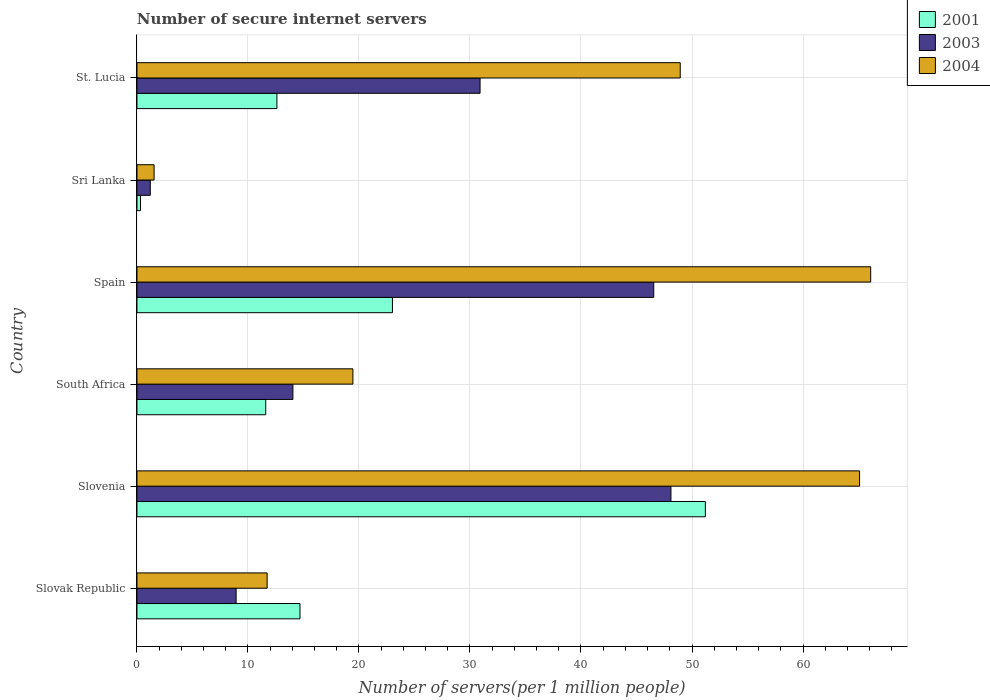How many groups of bars are there?
Your answer should be compact. 6. Are the number of bars on each tick of the Y-axis equal?
Offer a terse response. Yes. How many bars are there on the 6th tick from the top?
Make the answer very short. 3. How many bars are there on the 1st tick from the bottom?
Keep it short and to the point. 3. What is the label of the 4th group of bars from the top?
Provide a short and direct response. South Africa. What is the number of secure internet servers in 2001 in Slovak Republic?
Keep it short and to the point. 14.69. Across all countries, what is the maximum number of secure internet servers in 2004?
Your answer should be very brief. 66.1. Across all countries, what is the minimum number of secure internet servers in 2003?
Keep it short and to the point. 1.2. In which country was the number of secure internet servers in 2001 maximum?
Make the answer very short. Slovenia. In which country was the number of secure internet servers in 2003 minimum?
Ensure brevity in your answer.  Sri Lanka. What is the total number of secure internet servers in 2003 in the graph?
Offer a terse response. 149.75. What is the difference between the number of secure internet servers in 2004 in Slovak Republic and that in St. Lucia?
Your response must be concise. -37.21. What is the difference between the number of secure internet servers in 2001 in Sri Lanka and the number of secure internet servers in 2003 in Slovak Republic?
Provide a succinct answer. -8.61. What is the average number of secure internet servers in 2001 per country?
Ensure brevity in your answer.  18.91. What is the difference between the number of secure internet servers in 2001 and number of secure internet servers in 2004 in Spain?
Your answer should be very brief. -43.08. What is the ratio of the number of secure internet servers in 2001 in Slovenia to that in Sri Lanka?
Make the answer very short. 160.41. What is the difference between the highest and the second highest number of secure internet servers in 2003?
Your response must be concise. 1.55. What is the difference between the highest and the lowest number of secure internet servers in 2001?
Your answer should be very brief. 50.88. What does the 3rd bar from the top in St. Lucia represents?
Offer a very short reply. 2001. How many bars are there?
Ensure brevity in your answer.  18. Are all the bars in the graph horizontal?
Offer a terse response. Yes. Are the values on the major ticks of X-axis written in scientific E-notation?
Your answer should be compact. No. Does the graph contain any zero values?
Provide a succinct answer. No. Does the graph contain grids?
Make the answer very short. Yes. How are the legend labels stacked?
Your answer should be very brief. Vertical. What is the title of the graph?
Offer a very short reply. Number of secure internet servers. What is the label or title of the X-axis?
Your answer should be very brief. Number of servers(per 1 million people). What is the label or title of the Y-axis?
Make the answer very short. Country. What is the Number of servers(per 1 million people) in 2001 in Slovak Republic?
Give a very brief answer. 14.69. What is the Number of servers(per 1 million people) of 2003 in Slovak Republic?
Keep it short and to the point. 8.93. What is the Number of servers(per 1 million people) of 2004 in Slovak Republic?
Provide a succinct answer. 11.73. What is the Number of servers(per 1 million people) of 2001 in Slovenia?
Your response must be concise. 51.2. What is the Number of servers(per 1 million people) of 2003 in Slovenia?
Give a very brief answer. 48.1. What is the Number of servers(per 1 million people) in 2004 in Slovenia?
Offer a very short reply. 65.1. What is the Number of servers(per 1 million people) of 2001 in South Africa?
Your answer should be compact. 11.6. What is the Number of servers(per 1 million people) in 2003 in South Africa?
Provide a short and direct response. 14.05. What is the Number of servers(per 1 million people) of 2004 in South Africa?
Your answer should be very brief. 19.45. What is the Number of servers(per 1 million people) of 2001 in Spain?
Provide a succinct answer. 23.02. What is the Number of servers(per 1 million people) in 2003 in Spain?
Ensure brevity in your answer.  46.55. What is the Number of servers(per 1 million people) of 2004 in Spain?
Ensure brevity in your answer.  66.1. What is the Number of servers(per 1 million people) of 2001 in Sri Lanka?
Keep it short and to the point. 0.32. What is the Number of servers(per 1 million people) of 2003 in Sri Lanka?
Offer a terse response. 1.2. What is the Number of servers(per 1 million people) of 2004 in Sri Lanka?
Provide a short and direct response. 1.54. What is the Number of servers(per 1 million people) in 2001 in St. Lucia?
Provide a short and direct response. 12.61. What is the Number of servers(per 1 million people) in 2003 in St. Lucia?
Ensure brevity in your answer.  30.91. What is the Number of servers(per 1 million people) in 2004 in St. Lucia?
Your answer should be compact. 48.94. Across all countries, what is the maximum Number of servers(per 1 million people) in 2001?
Provide a short and direct response. 51.2. Across all countries, what is the maximum Number of servers(per 1 million people) in 2003?
Provide a succinct answer. 48.1. Across all countries, what is the maximum Number of servers(per 1 million people) in 2004?
Keep it short and to the point. 66.1. Across all countries, what is the minimum Number of servers(per 1 million people) of 2001?
Keep it short and to the point. 0.32. Across all countries, what is the minimum Number of servers(per 1 million people) of 2003?
Your answer should be very brief. 1.2. Across all countries, what is the minimum Number of servers(per 1 million people) in 2004?
Offer a very short reply. 1.54. What is the total Number of servers(per 1 million people) of 2001 in the graph?
Your answer should be very brief. 113.43. What is the total Number of servers(per 1 million people) in 2003 in the graph?
Ensure brevity in your answer.  149.75. What is the total Number of servers(per 1 million people) in 2004 in the graph?
Offer a terse response. 212.86. What is the difference between the Number of servers(per 1 million people) in 2001 in Slovak Republic and that in Slovenia?
Ensure brevity in your answer.  -36.52. What is the difference between the Number of servers(per 1 million people) of 2003 in Slovak Republic and that in Slovenia?
Your answer should be compact. -39.17. What is the difference between the Number of servers(per 1 million people) in 2004 in Slovak Republic and that in Slovenia?
Offer a very short reply. -53.37. What is the difference between the Number of servers(per 1 million people) of 2001 in Slovak Republic and that in South Africa?
Offer a terse response. 3.09. What is the difference between the Number of servers(per 1 million people) in 2003 in Slovak Republic and that in South Africa?
Offer a terse response. -5.12. What is the difference between the Number of servers(per 1 million people) in 2004 in Slovak Republic and that in South Africa?
Provide a short and direct response. -7.73. What is the difference between the Number of servers(per 1 million people) of 2001 in Slovak Republic and that in Spain?
Give a very brief answer. -8.33. What is the difference between the Number of servers(per 1 million people) of 2003 in Slovak Republic and that in Spain?
Give a very brief answer. -37.62. What is the difference between the Number of servers(per 1 million people) in 2004 in Slovak Republic and that in Spain?
Give a very brief answer. -54.37. What is the difference between the Number of servers(per 1 million people) in 2001 in Slovak Republic and that in Sri Lanka?
Offer a terse response. 14.37. What is the difference between the Number of servers(per 1 million people) of 2003 in Slovak Republic and that in Sri Lanka?
Make the answer very short. 7.73. What is the difference between the Number of servers(per 1 million people) in 2004 in Slovak Republic and that in Sri Lanka?
Keep it short and to the point. 10.18. What is the difference between the Number of servers(per 1 million people) in 2001 in Slovak Republic and that in St. Lucia?
Make the answer very short. 2.08. What is the difference between the Number of servers(per 1 million people) of 2003 in Slovak Republic and that in St. Lucia?
Offer a very short reply. -21.98. What is the difference between the Number of servers(per 1 million people) in 2004 in Slovak Republic and that in St. Lucia?
Provide a short and direct response. -37.21. What is the difference between the Number of servers(per 1 million people) of 2001 in Slovenia and that in South Africa?
Your response must be concise. 39.6. What is the difference between the Number of servers(per 1 million people) in 2003 in Slovenia and that in South Africa?
Your answer should be very brief. 34.05. What is the difference between the Number of servers(per 1 million people) of 2004 in Slovenia and that in South Africa?
Your answer should be very brief. 45.64. What is the difference between the Number of servers(per 1 million people) of 2001 in Slovenia and that in Spain?
Ensure brevity in your answer.  28.19. What is the difference between the Number of servers(per 1 million people) in 2003 in Slovenia and that in Spain?
Offer a terse response. 1.55. What is the difference between the Number of servers(per 1 million people) of 2004 in Slovenia and that in Spain?
Your answer should be very brief. -1. What is the difference between the Number of servers(per 1 million people) in 2001 in Slovenia and that in Sri Lanka?
Provide a short and direct response. 50.88. What is the difference between the Number of servers(per 1 million people) in 2003 in Slovenia and that in Sri Lanka?
Your response must be concise. 46.9. What is the difference between the Number of servers(per 1 million people) of 2004 in Slovenia and that in Sri Lanka?
Make the answer very short. 63.55. What is the difference between the Number of servers(per 1 million people) of 2001 in Slovenia and that in St. Lucia?
Make the answer very short. 38.6. What is the difference between the Number of servers(per 1 million people) in 2003 in Slovenia and that in St. Lucia?
Ensure brevity in your answer.  17.19. What is the difference between the Number of servers(per 1 million people) of 2004 in Slovenia and that in St. Lucia?
Give a very brief answer. 16.16. What is the difference between the Number of servers(per 1 million people) of 2001 in South Africa and that in Spain?
Provide a short and direct response. -11.41. What is the difference between the Number of servers(per 1 million people) in 2003 in South Africa and that in Spain?
Give a very brief answer. -32.51. What is the difference between the Number of servers(per 1 million people) of 2004 in South Africa and that in Spain?
Keep it short and to the point. -46.64. What is the difference between the Number of servers(per 1 million people) of 2001 in South Africa and that in Sri Lanka?
Provide a succinct answer. 11.28. What is the difference between the Number of servers(per 1 million people) in 2003 in South Africa and that in Sri Lanka?
Provide a short and direct response. 12.85. What is the difference between the Number of servers(per 1 million people) in 2004 in South Africa and that in Sri Lanka?
Your response must be concise. 17.91. What is the difference between the Number of servers(per 1 million people) in 2001 in South Africa and that in St. Lucia?
Your answer should be compact. -1.01. What is the difference between the Number of servers(per 1 million people) in 2003 in South Africa and that in St. Lucia?
Your answer should be very brief. -16.86. What is the difference between the Number of servers(per 1 million people) in 2004 in South Africa and that in St. Lucia?
Make the answer very short. -29.49. What is the difference between the Number of servers(per 1 million people) of 2001 in Spain and that in Sri Lanka?
Keep it short and to the point. 22.7. What is the difference between the Number of servers(per 1 million people) in 2003 in Spain and that in Sri Lanka?
Offer a very short reply. 45.35. What is the difference between the Number of servers(per 1 million people) in 2004 in Spain and that in Sri Lanka?
Offer a very short reply. 64.55. What is the difference between the Number of servers(per 1 million people) in 2001 in Spain and that in St. Lucia?
Offer a terse response. 10.41. What is the difference between the Number of servers(per 1 million people) in 2003 in Spain and that in St. Lucia?
Provide a succinct answer. 15.65. What is the difference between the Number of servers(per 1 million people) of 2004 in Spain and that in St. Lucia?
Keep it short and to the point. 17.16. What is the difference between the Number of servers(per 1 million people) in 2001 in Sri Lanka and that in St. Lucia?
Make the answer very short. -12.29. What is the difference between the Number of servers(per 1 million people) of 2003 in Sri Lanka and that in St. Lucia?
Give a very brief answer. -29.71. What is the difference between the Number of servers(per 1 million people) of 2004 in Sri Lanka and that in St. Lucia?
Keep it short and to the point. -47.4. What is the difference between the Number of servers(per 1 million people) of 2001 in Slovak Republic and the Number of servers(per 1 million people) of 2003 in Slovenia?
Your answer should be compact. -33.42. What is the difference between the Number of servers(per 1 million people) in 2001 in Slovak Republic and the Number of servers(per 1 million people) in 2004 in Slovenia?
Your answer should be very brief. -50.41. What is the difference between the Number of servers(per 1 million people) of 2003 in Slovak Republic and the Number of servers(per 1 million people) of 2004 in Slovenia?
Provide a succinct answer. -56.16. What is the difference between the Number of servers(per 1 million people) in 2001 in Slovak Republic and the Number of servers(per 1 million people) in 2003 in South Africa?
Offer a very short reply. 0.64. What is the difference between the Number of servers(per 1 million people) in 2001 in Slovak Republic and the Number of servers(per 1 million people) in 2004 in South Africa?
Your answer should be compact. -4.77. What is the difference between the Number of servers(per 1 million people) of 2003 in Slovak Republic and the Number of servers(per 1 million people) of 2004 in South Africa?
Provide a succinct answer. -10.52. What is the difference between the Number of servers(per 1 million people) of 2001 in Slovak Republic and the Number of servers(per 1 million people) of 2003 in Spain?
Ensure brevity in your answer.  -31.87. What is the difference between the Number of servers(per 1 million people) of 2001 in Slovak Republic and the Number of servers(per 1 million people) of 2004 in Spain?
Give a very brief answer. -51.41. What is the difference between the Number of servers(per 1 million people) of 2003 in Slovak Republic and the Number of servers(per 1 million people) of 2004 in Spain?
Make the answer very short. -57.16. What is the difference between the Number of servers(per 1 million people) of 2001 in Slovak Republic and the Number of servers(per 1 million people) of 2003 in Sri Lanka?
Your answer should be compact. 13.49. What is the difference between the Number of servers(per 1 million people) of 2001 in Slovak Republic and the Number of servers(per 1 million people) of 2004 in Sri Lanka?
Keep it short and to the point. 13.14. What is the difference between the Number of servers(per 1 million people) in 2003 in Slovak Republic and the Number of servers(per 1 million people) in 2004 in Sri Lanka?
Your answer should be very brief. 7.39. What is the difference between the Number of servers(per 1 million people) in 2001 in Slovak Republic and the Number of servers(per 1 million people) in 2003 in St. Lucia?
Make the answer very short. -16.22. What is the difference between the Number of servers(per 1 million people) in 2001 in Slovak Republic and the Number of servers(per 1 million people) in 2004 in St. Lucia?
Provide a succinct answer. -34.25. What is the difference between the Number of servers(per 1 million people) of 2003 in Slovak Republic and the Number of servers(per 1 million people) of 2004 in St. Lucia?
Give a very brief answer. -40.01. What is the difference between the Number of servers(per 1 million people) in 2001 in Slovenia and the Number of servers(per 1 million people) in 2003 in South Africa?
Ensure brevity in your answer.  37.16. What is the difference between the Number of servers(per 1 million people) in 2001 in Slovenia and the Number of servers(per 1 million people) in 2004 in South Africa?
Offer a terse response. 31.75. What is the difference between the Number of servers(per 1 million people) in 2003 in Slovenia and the Number of servers(per 1 million people) in 2004 in South Africa?
Your answer should be very brief. 28.65. What is the difference between the Number of servers(per 1 million people) in 2001 in Slovenia and the Number of servers(per 1 million people) in 2003 in Spain?
Offer a very short reply. 4.65. What is the difference between the Number of servers(per 1 million people) of 2001 in Slovenia and the Number of servers(per 1 million people) of 2004 in Spain?
Ensure brevity in your answer.  -14.89. What is the difference between the Number of servers(per 1 million people) in 2003 in Slovenia and the Number of servers(per 1 million people) in 2004 in Spain?
Offer a terse response. -17.99. What is the difference between the Number of servers(per 1 million people) in 2001 in Slovenia and the Number of servers(per 1 million people) in 2003 in Sri Lanka?
Keep it short and to the point. 50. What is the difference between the Number of servers(per 1 million people) of 2001 in Slovenia and the Number of servers(per 1 million people) of 2004 in Sri Lanka?
Your answer should be very brief. 49.66. What is the difference between the Number of servers(per 1 million people) in 2003 in Slovenia and the Number of servers(per 1 million people) in 2004 in Sri Lanka?
Provide a succinct answer. 46.56. What is the difference between the Number of servers(per 1 million people) in 2001 in Slovenia and the Number of servers(per 1 million people) in 2003 in St. Lucia?
Make the answer very short. 20.29. What is the difference between the Number of servers(per 1 million people) in 2001 in Slovenia and the Number of servers(per 1 million people) in 2004 in St. Lucia?
Ensure brevity in your answer.  2.26. What is the difference between the Number of servers(per 1 million people) in 2003 in Slovenia and the Number of servers(per 1 million people) in 2004 in St. Lucia?
Provide a short and direct response. -0.84. What is the difference between the Number of servers(per 1 million people) in 2001 in South Africa and the Number of servers(per 1 million people) in 2003 in Spain?
Offer a terse response. -34.95. What is the difference between the Number of servers(per 1 million people) in 2001 in South Africa and the Number of servers(per 1 million people) in 2004 in Spain?
Your answer should be very brief. -54.5. What is the difference between the Number of servers(per 1 million people) of 2003 in South Africa and the Number of servers(per 1 million people) of 2004 in Spain?
Provide a short and direct response. -52.05. What is the difference between the Number of servers(per 1 million people) in 2001 in South Africa and the Number of servers(per 1 million people) in 2003 in Sri Lanka?
Your answer should be compact. 10.4. What is the difference between the Number of servers(per 1 million people) in 2001 in South Africa and the Number of servers(per 1 million people) in 2004 in Sri Lanka?
Make the answer very short. 10.06. What is the difference between the Number of servers(per 1 million people) in 2003 in South Africa and the Number of servers(per 1 million people) in 2004 in Sri Lanka?
Provide a short and direct response. 12.5. What is the difference between the Number of servers(per 1 million people) in 2001 in South Africa and the Number of servers(per 1 million people) in 2003 in St. Lucia?
Ensure brevity in your answer.  -19.31. What is the difference between the Number of servers(per 1 million people) of 2001 in South Africa and the Number of servers(per 1 million people) of 2004 in St. Lucia?
Provide a succinct answer. -37.34. What is the difference between the Number of servers(per 1 million people) of 2003 in South Africa and the Number of servers(per 1 million people) of 2004 in St. Lucia?
Give a very brief answer. -34.89. What is the difference between the Number of servers(per 1 million people) of 2001 in Spain and the Number of servers(per 1 million people) of 2003 in Sri Lanka?
Provide a short and direct response. 21.82. What is the difference between the Number of servers(per 1 million people) in 2001 in Spain and the Number of servers(per 1 million people) in 2004 in Sri Lanka?
Provide a succinct answer. 21.47. What is the difference between the Number of servers(per 1 million people) of 2003 in Spain and the Number of servers(per 1 million people) of 2004 in Sri Lanka?
Your answer should be very brief. 45.01. What is the difference between the Number of servers(per 1 million people) of 2001 in Spain and the Number of servers(per 1 million people) of 2003 in St. Lucia?
Offer a very short reply. -7.89. What is the difference between the Number of servers(per 1 million people) of 2001 in Spain and the Number of servers(per 1 million people) of 2004 in St. Lucia?
Ensure brevity in your answer.  -25.93. What is the difference between the Number of servers(per 1 million people) in 2003 in Spain and the Number of servers(per 1 million people) in 2004 in St. Lucia?
Provide a succinct answer. -2.39. What is the difference between the Number of servers(per 1 million people) of 2001 in Sri Lanka and the Number of servers(per 1 million people) of 2003 in St. Lucia?
Give a very brief answer. -30.59. What is the difference between the Number of servers(per 1 million people) of 2001 in Sri Lanka and the Number of servers(per 1 million people) of 2004 in St. Lucia?
Keep it short and to the point. -48.62. What is the difference between the Number of servers(per 1 million people) of 2003 in Sri Lanka and the Number of servers(per 1 million people) of 2004 in St. Lucia?
Your response must be concise. -47.74. What is the average Number of servers(per 1 million people) of 2001 per country?
Make the answer very short. 18.91. What is the average Number of servers(per 1 million people) in 2003 per country?
Ensure brevity in your answer.  24.96. What is the average Number of servers(per 1 million people) of 2004 per country?
Provide a succinct answer. 35.48. What is the difference between the Number of servers(per 1 million people) of 2001 and Number of servers(per 1 million people) of 2003 in Slovak Republic?
Offer a very short reply. 5.75. What is the difference between the Number of servers(per 1 million people) in 2001 and Number of servers(per 1 million people) in 2004 in Slovak Republic?
Make the answer very short. 2.96. What is the difference between the Number of servers(per 1 million people) of 2003 and Number of servers(per 1 million people) of 2004 in Slovak Republic?
Offer a very short reply. -2.79. What is the difference between the Number of servers(per 1 million people) of 2001 and Number of servers(per 1 million people) of 2003 in Slovenia?
Provide a succinct answer. 3.1. What is the difference between the Number of servers(per 1 million people) in 2001 and Number of servers(per 1 million people) in 2004 in Slovenia?
Give a very brief answer. -13.89. What is the difference between the Number of servers(per 1 million people) in 2003 and Number of servers(per 1 million people) in 2004 in Slovenia?
Offer a very short reply. -16.99. What is the difference between the Number of servers(per 1 million people) of 2001 and Number of servers(per 1 million people) of 2003 in South Africa?
Give a very brief answer. -2.45. What is the difference between the Number of servers(per 1 million people) of 2001 and Number of servers(per 1 million people) of 2004 in South Africa?
Your response must be concise. -7.85. What is the difference between the Number of servers(per 1 million people) in 2003 and Number of servers(per 1 million people) in 2004 in South Africa?
Provide a short and direct response. -5.41. What is the difference between the Number of servers(per 1 million people) in 2001 and Number of servers(per 1 million people) in 2003 in Spain?
Provide a short and direct response. -23.54. What is the difference between the Number of servers(per 1 million people) in 2001 and Number of servers(per 1 million people) in 2004 in Spain?
Keep it short and to the point. -43.08. What is the difference between the Number of servers(per 1 million people) in 2003 and Number of servers(per 1 million people) in 2004 in Spain?
Offer a terse response. -19.54. What is the difference between the Number of servers(per 1 million people) of 2001 and Number of servers(per 1 million people) of 2003 in Sri Lanka?
Keep it short and to the point. -0.88. What is the difference between the Number of servers(per 1 million people) of 2001 and Number of servers(per 1 million people) of 2004 in Sri Lanka?
Offer a terse response. -1.22. What is the difference between the Number of servers(per 1 million people) in 2003 and Number of servers(per 1 million people) in 2004 in Sri Lanka?
Make the answer very short. -0.34. What is the difference between the Number of servers(per 1 million people) in 2001 and Number of servers(per 1 million people) in 2003 in St. Lucia?
Your response must be concise. -18.3. What is the difference between the Number of servers(per 1 million people) in 2001 and Number of servers(per 1 million people) in 2004 in St. Lucia?
Your answer should be compact. -36.33. What is the difference between the Number of servers(per 1 million people) of 2003 and Number of servers(per 1 million people) of 2004 in St. Lucia?
Offer a very short reply. -18.03. What is the ratio of the Number of servers(per 1 million people) in 2001 in Slovak Republic to that in Slovenia?
Your response must be concise. 0.29. What is the ratio of the Number of servers(per 1 million people) of 2003 in Slovak Republic to that in Slovenia?
Your answer should be very brief. 0.19. What is the ratio of the Number of servers(per 1 million people) of 2004 in Slovak Republic to that in Slovenia?
Make the answer very short. 0.18. What is the ratio of the Number of servers(per 1 million people) of 2001 in Slovak Republic to that in South Africa?
Offer a very short reply. 1.27. What is the ratio of the Number of servers(per 1 million people) of 2003 in Slovak Republic to that in South Africa?
Offer a very short reply. 0.64. What is the ratio of the Number of servers(per 1 million people) of 2004 in Slovak Republic to that in South Africa?
Offer a terse response. 0.6. What is the ratio of the Number of servers(per 1 million people) of 2001 in Slovak Republic to that in Spain?
Provide a succinct answer. 0.64. What is the ratio of the Number of servers(per 1 million people) in 2003 in Slovak Republic to that in Spain?
Offer a terse response. 0.19. What is the ratio of the Number of servers(per 1 million people) in 2004 in Slovak Republic to that in Spain?
Ensure brevity in your answer.  0.18. What is the ratio of the Number of servers(per 1 million people) of 2001 in Slovak Republic to that in Sri Lanka?
Make the answer very short. 46.01. What is the ratio of the Number of servers(per 1 million people) in 2003 in Slovak Republic to that in Sri Lanka?
Your response must be concise. 7.45. What is the ratio of the Number of servers(per 1 million people) in 2004 in Slovak Republic to that in Sri Lanka?
Keep it short and to the point. 7.6. What is the ratio of the Number of servers(per 1 million people) of 2001 in Slovak Republic to that in St. Lucia?
Provide a succinct answer. 1.17. What is the ratio of the Number of servers(per 1 million people) in 2003 in Slovak Republic to that in St. Lucia?
Keep it short and to the point. 0.29. What is the ratio of the Number of servers(per 1 million people) of 2004 in Slovak Republic to that in St. Lucia?
Offer a terse response. 0.24. What is the ratio of the Number of servers(per 1 million people) in 2001 in Slovenia to that in South Africa?
Your answer should be compact. 4.41. What is the ratio of the Number of servers(per 1 million people) of 2003 in Slovenia to that in South Africa?
Provide a short and direct response. 3.42. What is the ratio of the Number of servers(per 1 million people) of 2004 in Slovenia to that in South Africa?
Your answer should be compact. 3.35. What is the ratio of the Number of servers(per 1 million people) in 2001 in Slovenia to that in Spain?
Make the answer very short. 2.22. What is the ratio of the Number of servers(per 1 million people) in 2004 in Slovenia to that in Spain?
Make the answer very short. 0.98. What is the ratio of the Number of servers(per 1 million people) in 2001 in Slovenia to that in Sri Lanka?
Your answer should be very brief. 160.41. What is the ratio of the Number of servers(per 1 million people) in 2003 in Slovenia to that in Sri Lanka?
Give a very brief answer. 40.1. What is the ratio of the Number of servers(per 1 million people) of 2004 in Slovenia to that in Sri Lanka?
Provide a short and direct response. 42.17. What is the ratio of the Number of servers(per 1 million people) of 2001 in Slovenia to that in St. Lucia?
Your answer should be very brief. 4.06. What is the ratio of the Number of servers(per 1 million people) of 2003 in Slovenia to that in St. Lucia?
Offer a very short reply. 1.56. What is the ratio of the Number of servers(per 1 million people) in 2004 in Slovenia to that in St. Lucia?
Your answer should be compact. 1.33. What is the ratio of the Number of servers(per 1 million people) of 2001 in South Africa to that in Spain?
Your response must be concise. 0.5. What is the ratio of the Number of servers(per 1 million people) in 2003 in South Africa to that in Spain?
Offer a terse response. 0.3. What is the ratio of the Number of servers(per 1 million people) of 2004 in South Africa to that in Spain?
Offer a very short reply. 0.29. What is the ratio of the Number of servers(per 1 million people) in 2001 in South Africa to that in Sri Lanka?
Give a very brief answer. 36.34. What is the ratio of the Number of servers(per 1 million people) in 2003 in South Africa to that in Sri Lanka?
Your answer should be very brief. 11.71. What is the ratio of the Number of servers(per 1 million people) in 2004 in South Africa to that in Sri Lanka?
Offer a terse response. 12.6. What is the ratio of the Number of servers(per 1 million people) in 2001 in South Africa to that in St. Lucia?
Provide a short and direct response. 0.92. What is the ratio of the Number of servers(per 1 million people) in 2003 in South Africa to that in St. Lucia?
Your answer should be compact. 0.45. What is the ratio of the Number of servers(per 1 million people) in 2004 in South Africa to that in St. Lucia?
Your answer should be very brief. 0.4. What is the ratio of the Number of servers(per 1 million people) of 2001 in Spain to that in Sri Lanka?
Your answer should be compact. 72.1. What is the ratio of the Number of servers(per 1 million people) in 2003 in Spain to that in Sri Lanka?
Your response must be concise. 38.81. What is the ratio of the Number of servers(per 1 million people) in 2004 in Spain to that in Sri Lanka?
Offer a terse response. 42.82. What is the ratio of the Number of servers(per 1 million people) in 2001 in Spain to that in St. Lucia?
Your answer should be compact. 1.83. What is the ratio of the Number of servers(per 1 million people) of 2003 in Spain to that in St. Lucia?
Provide a short and direct response. 1.51. What is the ratio of the Number of servers(per 1 million people) in 2004 in Spain to that in St. Lucia?
Ensure brevity in your answer.  1.35. What is the ratio of the Number of servers(per 1 million people) of 2001 in Sri Lanka to that in St. Lucia?
Offer a very short reply. 0.03. What is the ratio of the Number of servers(per 1 million people) in 2003 in Sri Lanka to that in St. Lucia?
Make the answer very short. 0.04. What is the ratio of the Number of servers(per 1 million people) in 2004 in Sri Lanka to that in St. Lucia?
Provide a succinct answer. 0.03. What is the difference between the highest and the second highest Number of servers(per 1 million people) of 2001?
Ensure brevity in your answer.  28.19. What is the difference between the highest and the second highest Number of servers(per 1 million people) in 2003?
Keep it short and to the point. 1.55. What is the difference between the highest and the second highest Number of servers(per 1 million people) in 2004?
Your answer should be compact. 1. What is the difference between the highest and the lowest Number of servers(per 1 million people) in 2001?
Give a very brief answer. 50.88. What is the difference between the highest and the lowest Number of servers(per 1 million people) in 2003?
Ensure brevity in your answer.  46.9. What is the difference between the highest and the lowest Number of servers(per 1 million people) in 2004?
Keep it short and to the point. 64.55. 